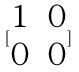Convert formula to latex. <formula><loc_0><loc_0><loc_500><loc_500>[ \begin{matrix} 1 & 0 \\ 0 & 0 \end{matrix} ]</formula> 